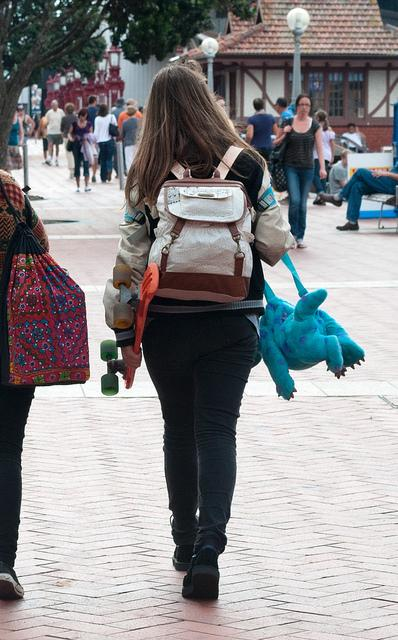What is the dominate color of the object the woman is carrying with her left arm? orange 